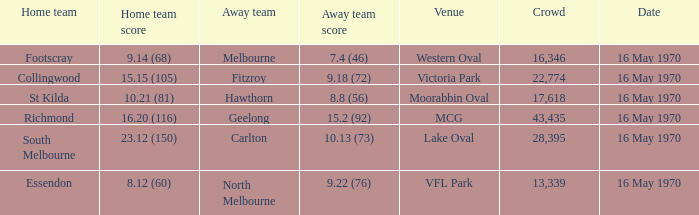When south melbourne was the home team, what score did the away team achieve? 10.13 (73). 